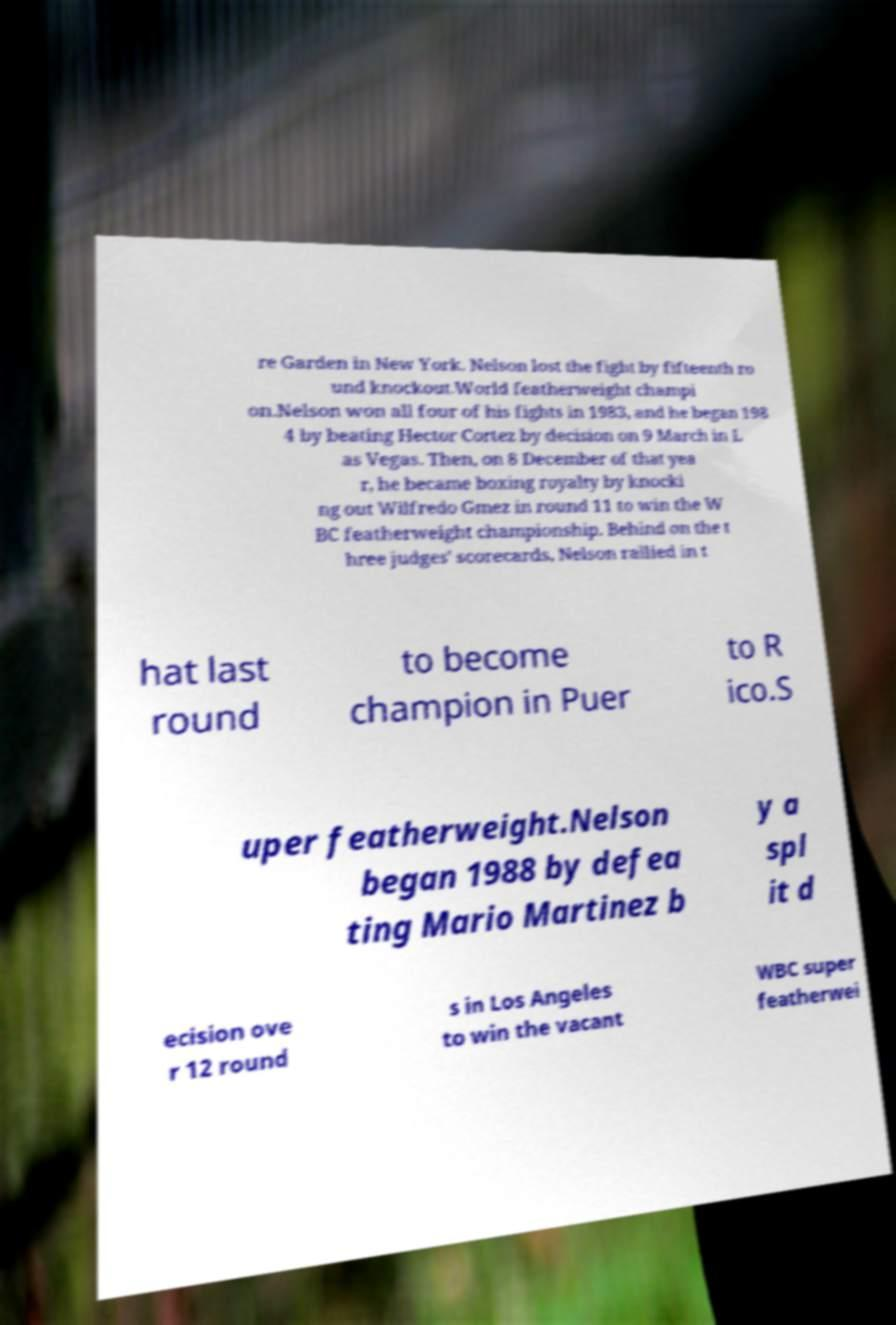For documentation purposes, I need the text within this image transcribed. Could you provide that? re Garden in New York. Nelson lost the fight by fifteenth ro und knockout.World featherweight champi on.Nelson won all four of his fights in 1983, and he began 198 4 by beating Hector Cortez by decision on 9 March in L as Vegas. Then, on 8 December of that yea r, he became boxing royalty by knocki ng out Wilfredo Gmez in round 11 to win the W BC featherweight championship. Behind on the t hree judges' scorecards, Nelson rallied in t hat last round to become champion in Puer to R ico.S uper featherweight.Nelson began 1988 by defea ting Mario Martinez b y a spl it d ecision ove r 12 round s in Los Angeles to win the vacant WBC super featherwei 